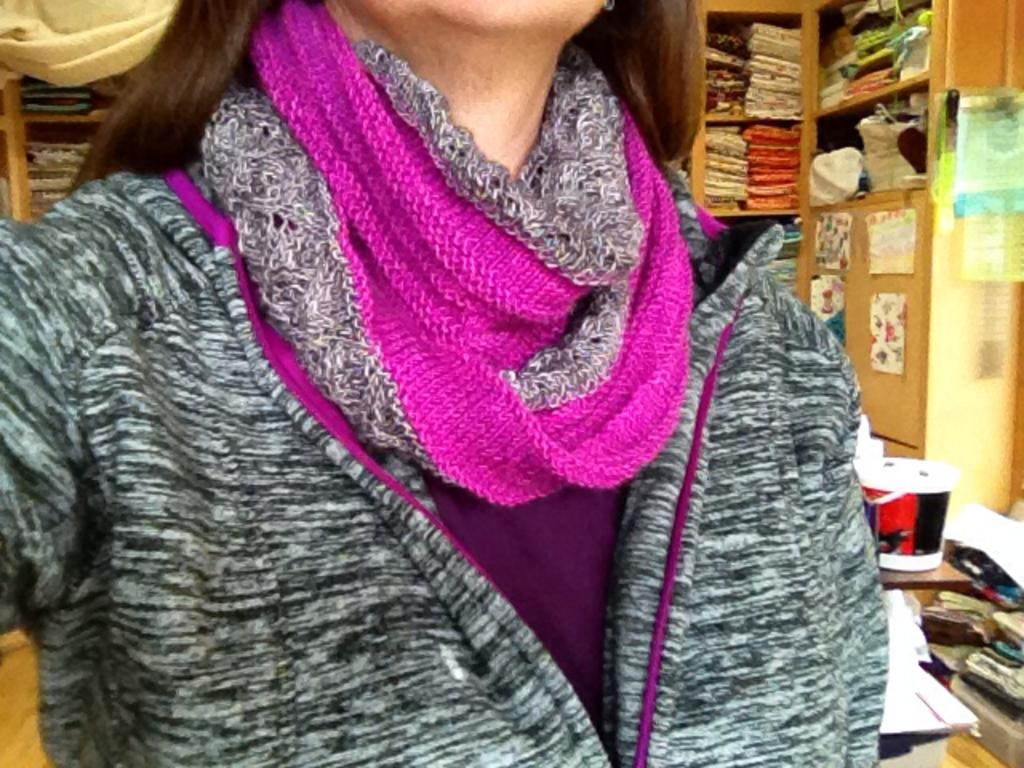What is present in the image? There is a person, shelves with objects, posters with images, and other objects in the image. Can you describe the person in the image? The person is partially visible (truncated) in the image. What can be found on the shelves in the image? There are objects on the shelves in the image. What is depicted on the posters in the image? The posters in the image have images on them. Can you tell me how many giraffes are present at the party in the image? There is no giraffe or party present in the image; it features a person, shelves with objects, posters with images, and other objects. How much does the ticket cost for the event in the image? There is no ticket or event present in the image. 